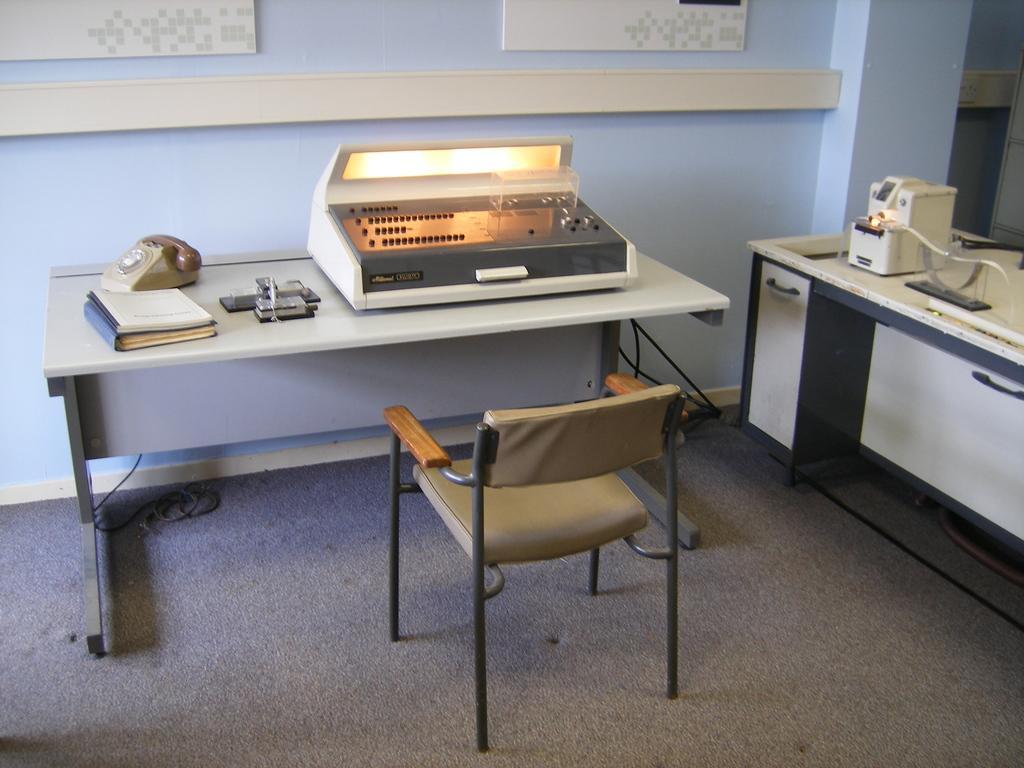Can you describe this image briefly? On these tables there are machines, telephone and books. Above this carpet there is a cable and chair. This is wall. 